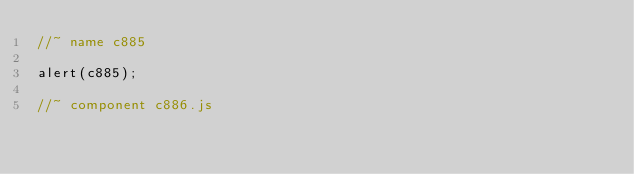<code> <loc_0><loc_0><loc_500><loc_500><_JavaScript_>//~ name c885

alert(c885);

//~ component c886.js

</code> 